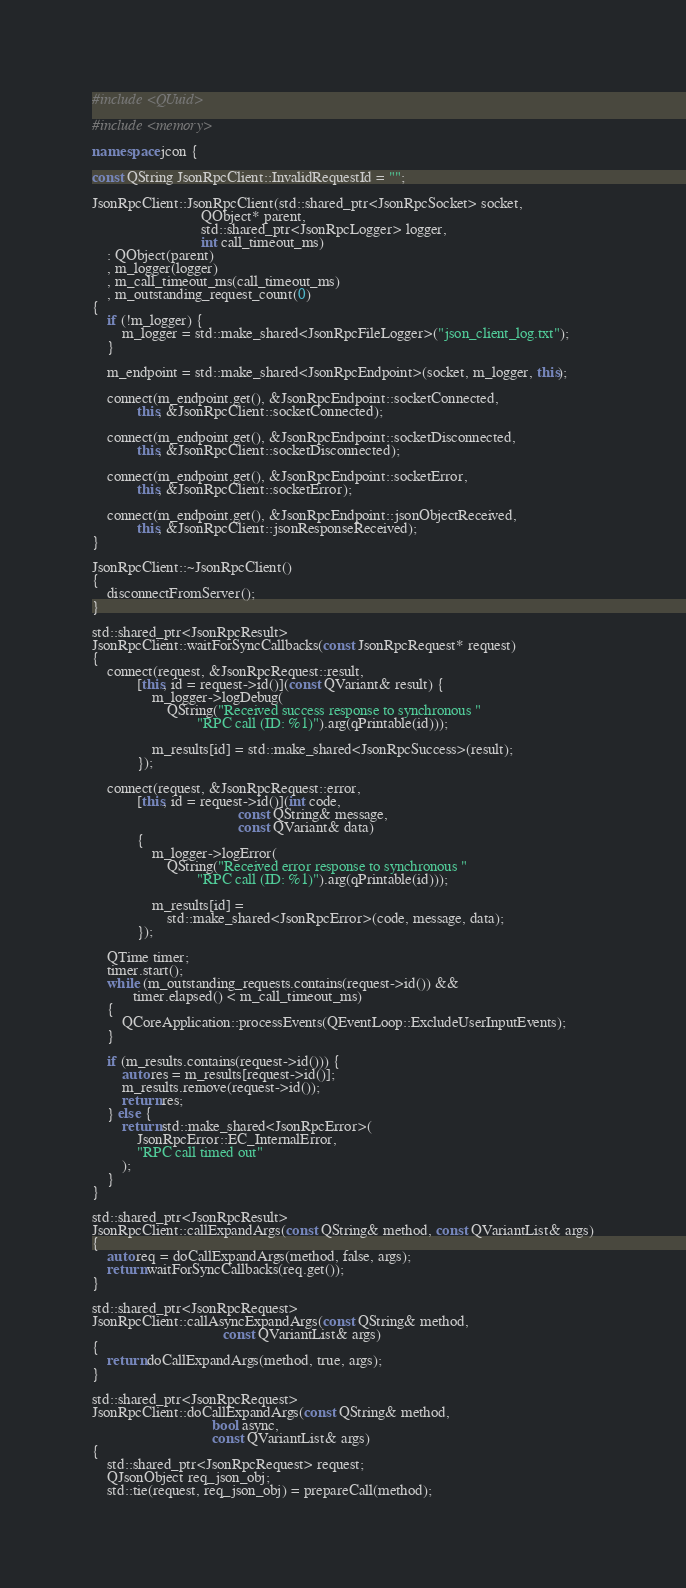Convert code to text. <code><loc_0><loc_0><loc_500><loc_500><_C++_>#include <QUuid>

#include <memory>

namespace jcon {

const QString JsonRpcClient::InvalidRequestId = "";

JsonRpcClient::JsonRpcClient(std::shared_ptr<JsonRpcSocket> socket,
                             QObject* parent,
                             std::shared_ptr<JsonRpcLogger> logger,
                             int call_timeout_ms)
    : QObject(parent)
    , m_logger(logger)
    , m_call_timeout_ms(call_timeout_ms)
    , m_outstanding_request_count(0)
{
    if (!m_logger) {
        m_logger = std::make_shared<JsonRpcFileLogger>("json_client_log.txt");
    }

    m_endpoint = std::make_shared<JsonRpcEndpoint>(socket, m_logger, this);

    connect(m_endpoint.get(), &JsonRpcEndpoint::socketConnected,
            this, &JsonRpcClient::socketConnected);

    connect(m_endpoint.get(), &JsonRpcEndpoint::socketDisconnected,
            this, &JsonRpcClient::socketDisconnected);

    connect(m_endpoint.get(), &JsonRpcEndpoint::socketError,
            this, &JsonRpcClient::socketError);

    connect(m_endpoint.get(), &JsonRpcEndpoint::jsonObjectReceived,
            this, &JsonRpcClient::jsonResponseReceived);
}

JsonRpcClient::~JsonRpcClient()
{
    disconnectFromServer();
}

std::shared_ptr<JsonRpcResult>
JsonRpcClient::waitForSyncCallbacks(const JsonRpcRequest* request)
{
    connect(request, &JsonRpcRequest::result,
            [this, id = request->id()](const QVariant& result) {
                m_logger->logDebug(
                    QString("Received success response to synchronous "
                            "RPC call (ID: %1)").arg(qPrintable(id)));

                m_results[id] = std::make_shared<JsonRpcSuccess>(result);
            });

    connect(request, &JsonRpcRequest::error,
            [this, id = request->id()](int code,
                                       const QString& message,
                                       const QVariant& data)
            {
                m_logger->logError(
                    QString("Received error response to synchronous "
                            "RPC call (ID: %1)").arg(qPrintable(id)));

                m_results[id] =
                    std::make_shared<JsonRpcError>(code, message, data);
            });

    QTime timer;
    timer.start();
    while (m_outstanding_requests.contains(request->id()) &&
           timer.elapsed() < m_call_timeout_ms)
    {
        QCoreApplication::processEvents(QEventLoop::ExcludeUserInputEvents);
    }

    if (m_results.contains(request->id())) {
        auto res = m_results[request->id()];
        m_results.remove(request->id());
        return res;
    } else {
        return std::make_shared<JsonRpcError>(
            JsonRpcError::EC_InternalError,
            "RPC call timed out"
        );
    }
}

std::shared_ptr<JsonRpcResult>
JsonRpcClient::callExpandArgs(const QString& method, const QVariantList& args)
{
    auto req = doCallExpandArgs(method, false, args);
    return waitForSyncCallbacks(req.get());
}

std::shared_ptr<JsonRpcRequest>
JsonRpcClient::callAsyncExpandArgs(const QString& method,
                                   const QVariantList& args)
{
    return doCallExpandArgs(method, true, args);
}

std::shared_ptr<JsonRpcRequest>
JsonRpcClient::doCallExpandArgs(const QString& method,
                                bool async,
                                const QVariantList& args)
{
    std::shared_ptr<JsonRpcRequest> request;
    QJsonObject req_json_obj;
    std::tie(request, req_json_obj) = prepareCall(method);
</code> 